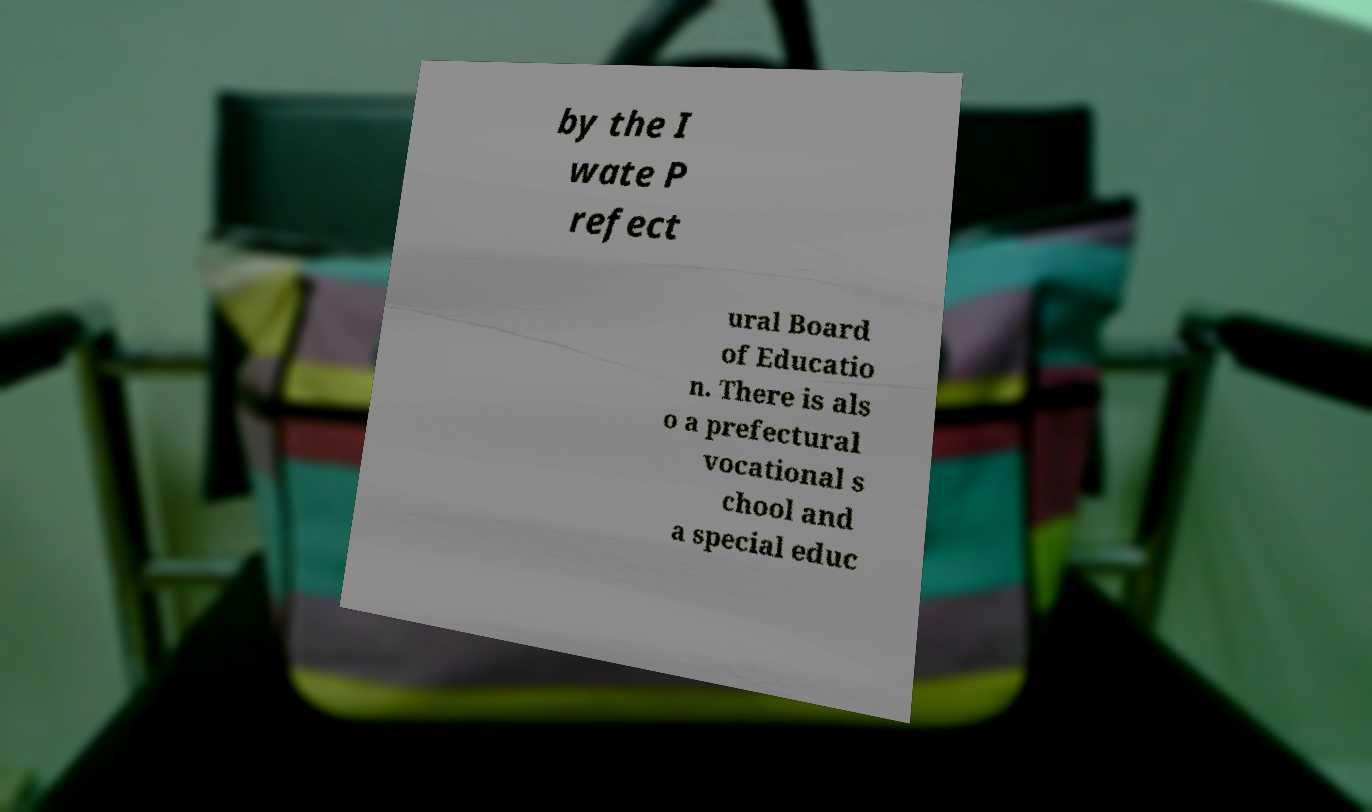Could you assist in decoding the text presented in this image and type it out clearly? by the I wate P refect ural Board of Educatio n. There is als o a prefectural vocational s chool and a special educ 